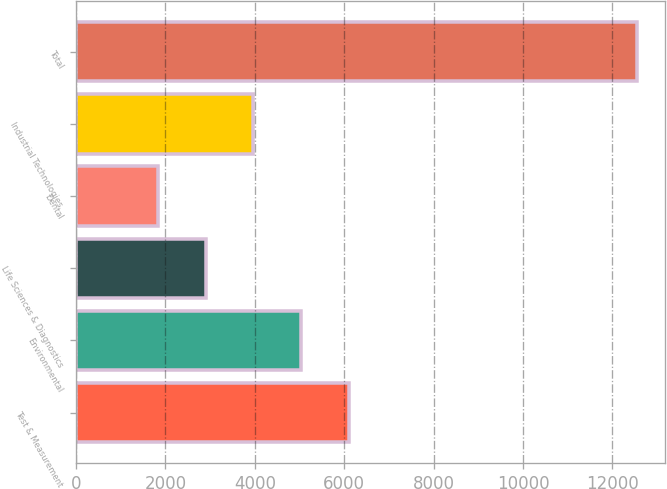Convert chart. <chart><loc_0><loc_0><loc_500><loc_500><bar_chart><fcel>Test & Measurement<fcel>Environmental<fcel>Life Sciences & Diagnostics<fcel>Dental<fcel>Industrial Technologies<fcel>Total<nl><fcel>6114.76<fcel>5042.22<fcel>2897.14<fcel>1824.6<fcel>3969.68<fcel>12550<nl></chart> 